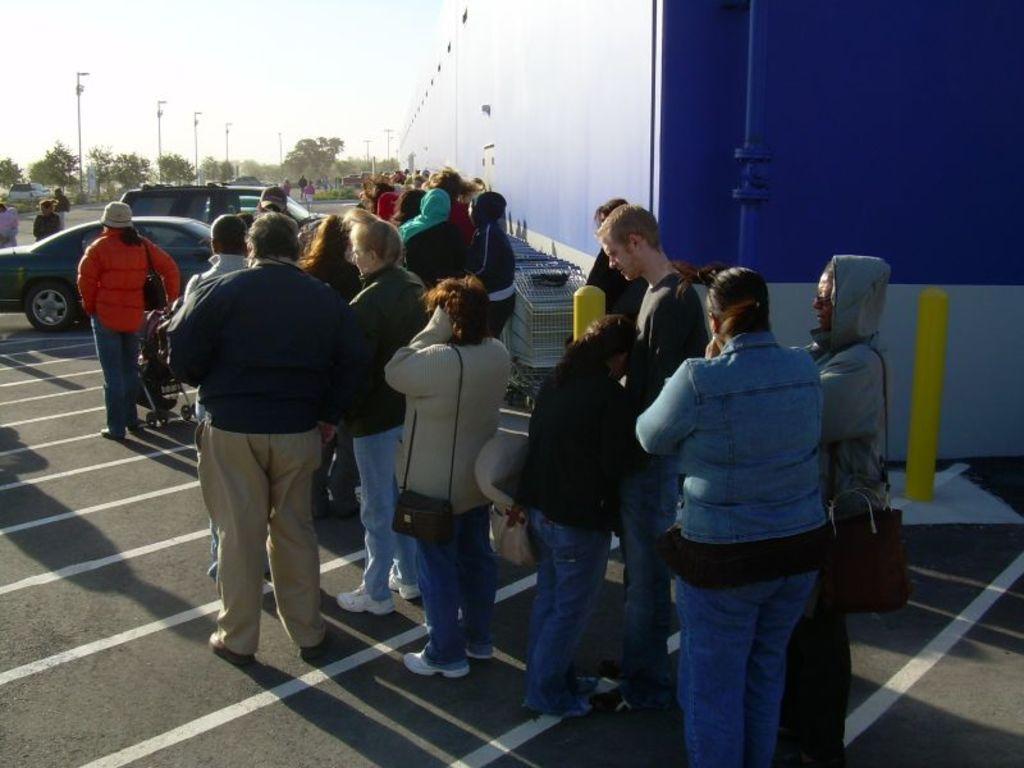Please provide a concise description of this image. This image is clicked outside. There is a store at the top. There are so many persons standing in the middle. There are cars on the left side. There are trees on the left side. There is sky at the top. 